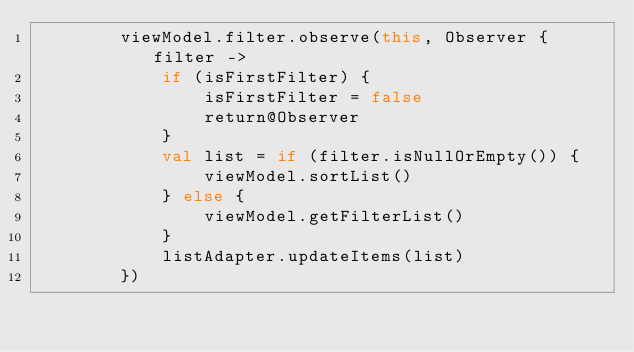<code> <loc_0><loc_0><loc_500><loc_500><_Kotlin_>        viewModel.filter.observe(this, Observer { filter ->
            if (isFirstFilter) {
                isFirstFilter = false
                return@Observer
            }
            val list = if (filter.isNullOrEmpty()) {
                viewModel.sortList()
            } else {
                viewModel.getFilterList()
            }
            listAdapter.updateItems(list)
        })</code> 